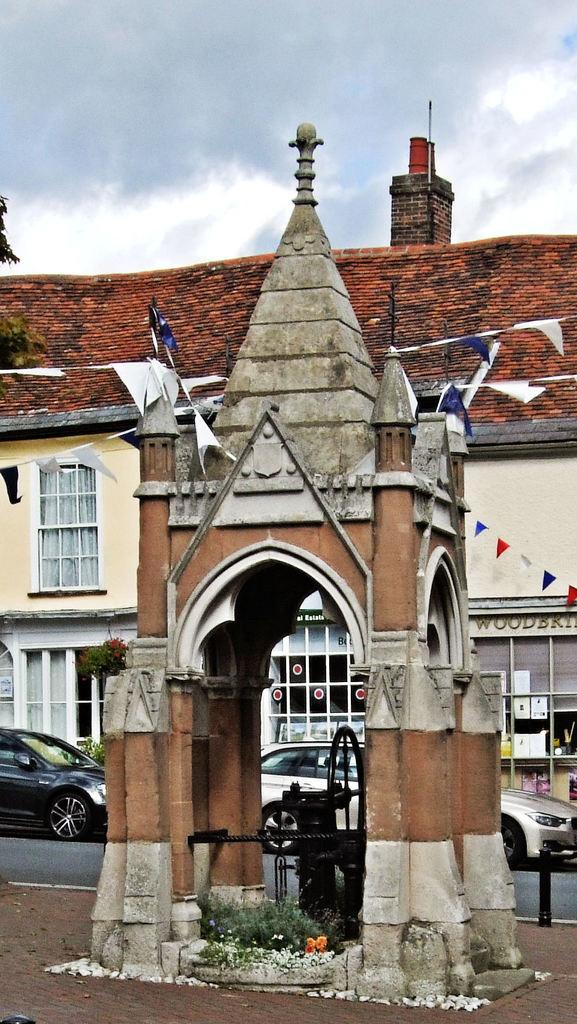What type of structures can be seen in the image? There are houses in the image. What feature of the houses is visible in the image? There are windows visible in the image. What type of vehicles can be seen on the road in the image? There are cars on the road in the image. What type of vegetation is present in the image? There are plants and trees in the image. What objects are tied to ropes in the image? There are papers tied to ropes in the image. What part of the natural environment is visible in the image? The sky is visible in the image. Where is the faucet located in the image? There is no faucet present in the image. How are the plants being measured in the image? There is no indication of measuring plants in the image. 